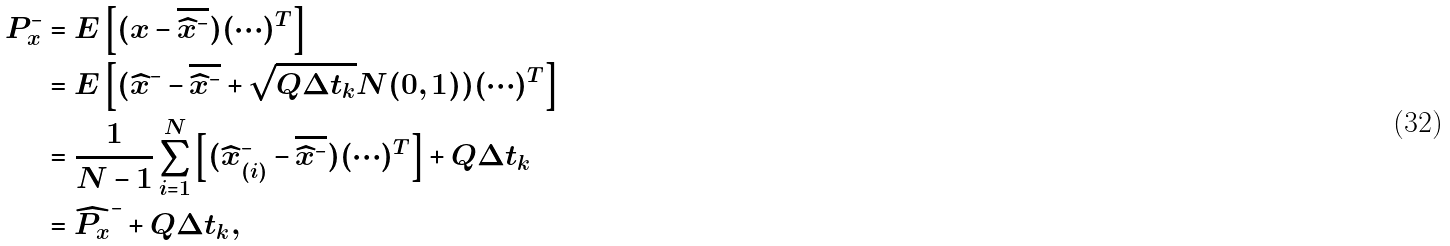<formula> <loc_0><loc_0><loc_500><loc_500>P _ { x } ^ { - } & = E \left [ ( x - \overline { \widehat { x } ^ { - } } ) ( \cdots ) ^ { T } \right ] \\ & = E \left [ ( \widehat { x } ^ { - } - \overline { \widehat { x } ^ { - } } + \sqrt { Q \Delta t _ { k } } N ( 0 , 1 ) ) ( \cdots ) ^ { T } \right ] \\ & = \frac { 1 } { N - 1 } \sum _ { i = 1 } ^ { N } { \left [ ( \widehat { x } _ { ( i ) } ^ { - } - \overline { \widehat { x } ^ { - } } ) ( \cdots ) ^ { T } \right ] } + Q \Delta t _ { k } \\ & = \widehat { P _ { x } } ^ { - } + Q \Delta t _ { k } ,</formula> 